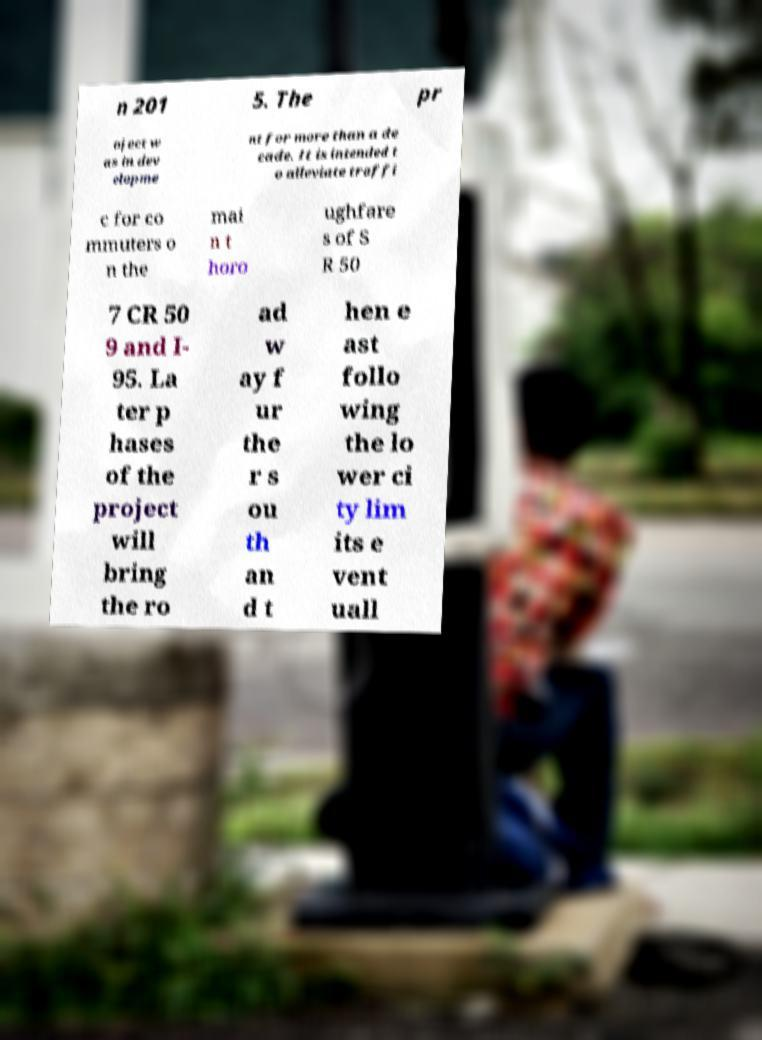Can you read and provide the text displayed in the image?This photo seems to have some interesting text. Can you extract and type it out for me? n 201 5. The pr oject w as in dev elopme nt for more than a de cade. It is intended t o alleviate traffi c for co mmuters o n the mai n t horo ughfare s of S R 50 7 CR 50 9 and I- 95. La ter p hases of the project will bring the ro ad w ay f ur the r s ou th an d t hen e ast follo wing the lo wer ci ty lim its e vent uall 